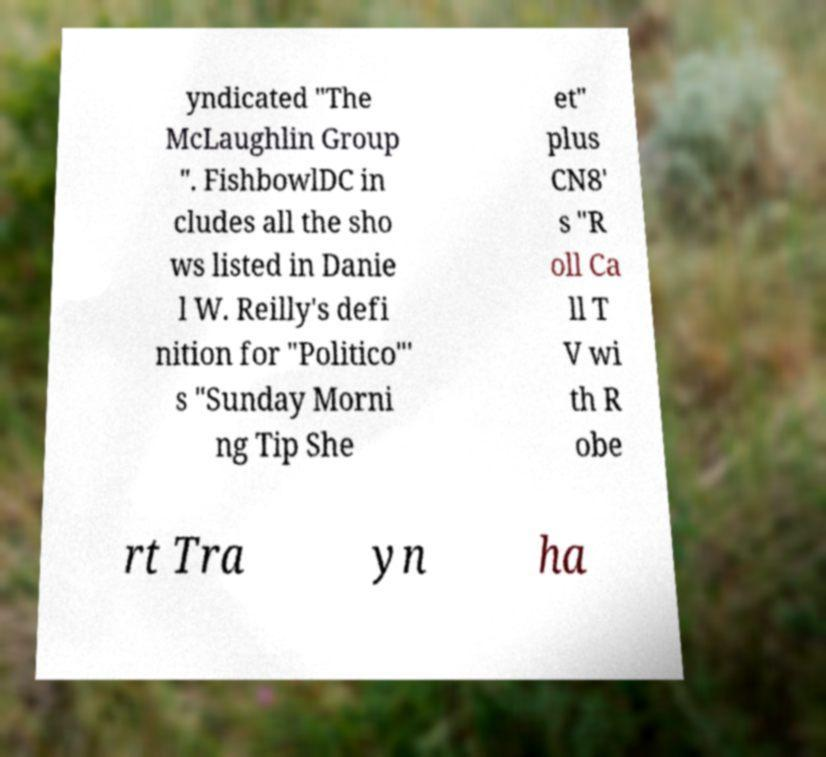For documentation purposes, I need the text within this image transcribed. Could you provide that? yndicated "The McLaughlin Group ". FishbowlDC in cludes all the sho ws listed in Danie l W. Reilly's defi nition for "Politico"' s "Sunday Morni ng Tip She et" plus CN8' s "R oll Ca ll T V wi th R obe rt Tra yn ha 